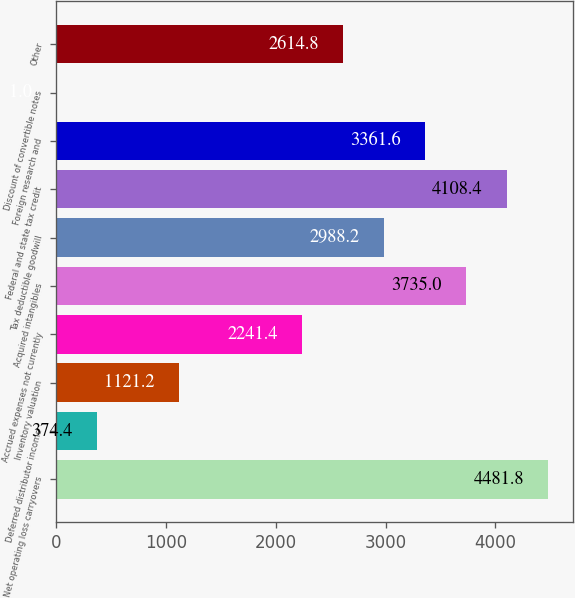<chart> <loc_0><loc_0><loc_500><loc_500><bar_chart><fcel>Net operating loss carryovers<fcel>Deferred distributor income<fcel>Inventory valuation<fcel>Accrued expenses not currently<fcel>Acquired intangibles<fcel>Tax deductible goodwill<fcel>Federal and state tax credit<fcel>Foreign research and<fcel>Discount of convertible notes<fcel>Other<nl><fcel>4481.8<fcel>374.4<fcel>1121.2<fcel>2241.4<fcel>3735<fcel>2988.2<fcel>4108.4<fcel>3361.6<fcel>1<fcel>2614.8<nl></chart> 